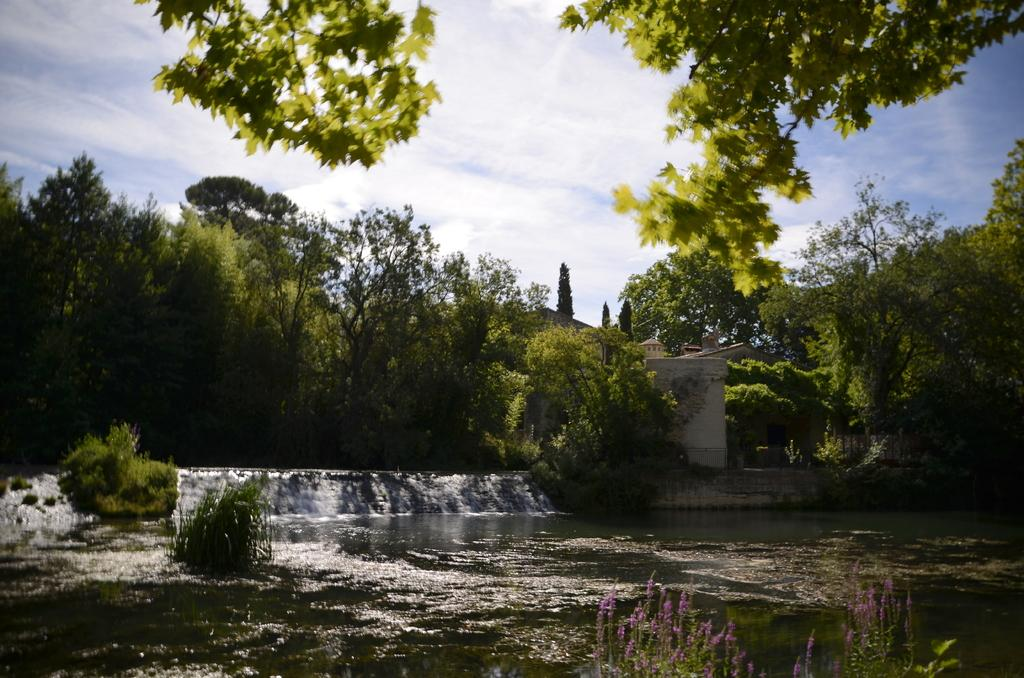What is the primary element present in the image? There is water in the image. What other natural elements can be seen in the image? There are plants and trees in the image. Are there any man-made structures visible? Yes, there is a building in the image. What can be seen in the background of the image? The sky is visible in the background of the image. What type of loaf is being baked in the oven in the image? There is no oven or loaf present in the image; it features water, plants, a building, trees, and the sky. 